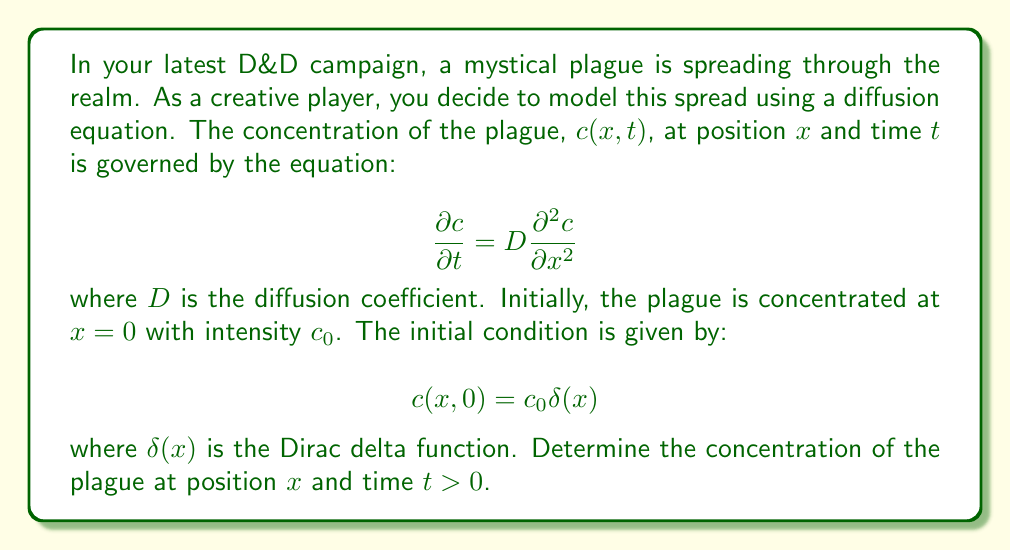What is the answer to this math problem? To solve this diffusion equation with the given initial condition, we'll follow these steps:

1) First, we recognize this as the heat equation in one dimension, with the concentration $c(x,t)$ replacing temperature.

2) The solution to this equation with a point source initial condition is known to be:

   $$c(x,t) = \frac{M}{\sqrt{4\pi Dt}} e^{-\frac{x^2}{4Dt}}$$

   where $M$ is the total amount of substance.

3) To determine $M$, we integrate the initial condition over all space:

   $$M = \int_{-\infty}^{\infty} c(x,0) dx = \int_{-\infty}^{\infty} c_0\delta(x) dx = c_0$$

4) Substituting this back into our solution:

   $$c(x,t) = \frac{c_0}{\sqrt{4\pi Dt}} e^{-\frac{x^2}{4Dt}}$$

5) This solution represents a Gaussian distribution that spreads out over time. The peak concentration (at $x=0$) decreases as $1/\sqrt{t}$, while the width of the distribution increases as $\sqrt{t}$.

6) We can verify that this solution satisfies the initial condition:
   
   $$\lim_{t \to 0} c(x,t) = c_0\delta(x)$$

   This is because as $t$ approaches 0, the Gaussian becomes infinitely tall and infinitely narrow, approaching a delta function.

7) We can also verify that it satisfies the diffusion equation by taking the appropriate derivatives and substituting them back into the equation.
Answer: The concentration of the plague at position $x$ and time $t > 0$ is given by:

$$c(x,t) = \frac{c_0}{\sqrt{4\pi Dt}} e^{-\frac{x^2}{4Dt}}$$

where $c_0$ is the initial concentration at $x=0$ and $D$ is the diffusion coefficient. 